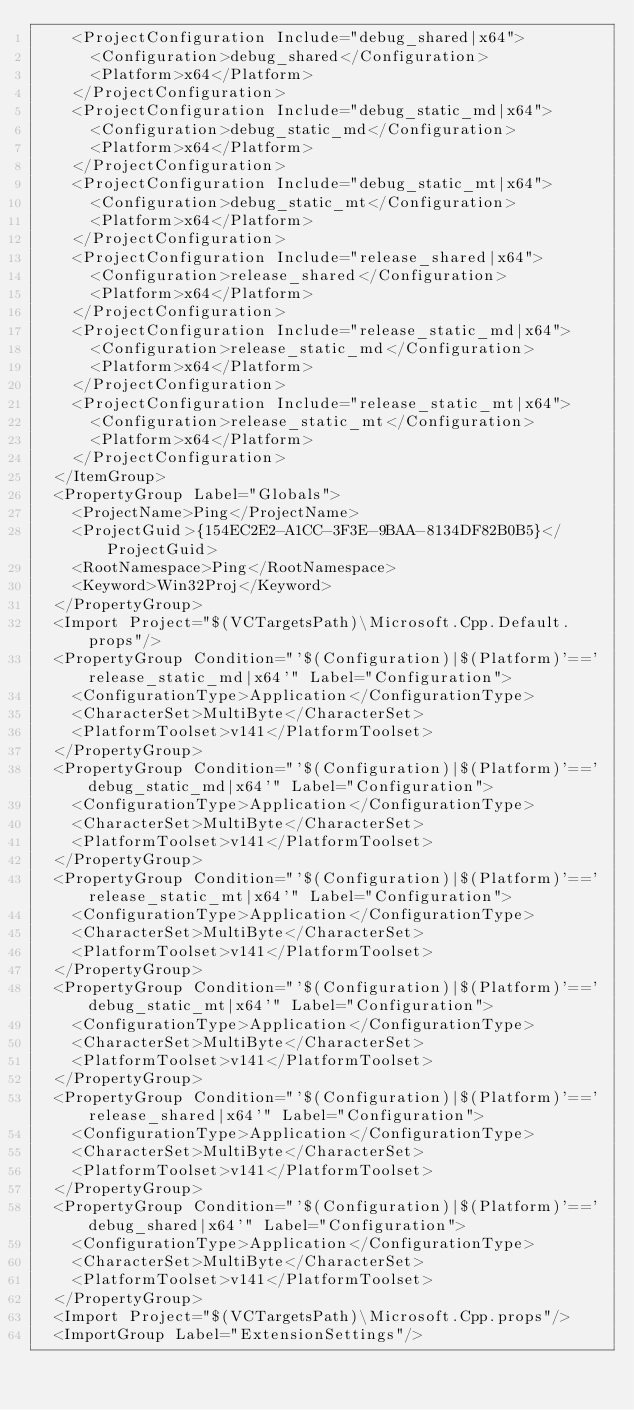<code> <loc_0><loc_0><loc_500><loc_500><_XML_>    <ProjectConfiguration Include="debug_shared|x64">
      <Configuration>debug_shared</Configuration>
      <Platform>x64</Platform>
    </ProjectConfiguration>
    <ProjectConfiguration Include="debug_static_md|x64">
      <Configuration>debug_static_md</Configuration>
      <Platform>x64</Platform>
    </ProjectConfiguration>
    <ProjectConfiguration Include="debug_static_mt|x64">
      <Configuration>debug_static_mt</Configuration>
      <Platform>x64</Platform>
    </ProjectConfiguration>
    <ProjectConfiguration Include="release_shared|x64">
      <Configuration>release_shared</Configuration>
      <Platform>x64</Platform>
    </ProjectConfiguration>
    <ProjectConfiguration Include="release_static_md|x64">
      <Configuration>release_static_md</Configuration>
      <Platform>x64</Platform>
    </ProjectConfiguration>
    <ProjectConfiguration Include="release_static_mt|x64">
      <Configuration>release_static_mt</Configuration>
      <Platform>x64</Platform>
    </ProjectConfiguration>
  </ItemGroup>
  <PropertyGroup Label="Globals">
    <ProjectName>Ping</ProjectName>
    <ProjectGuid>{154EC2E2-A1CC-3F3E-9BAA-8134DF82B0B5}</ProjectGuid>
    <RootNamespace>Ping</RootNamespace>
    <Keyword>Win32Proj</Keyword>
  </PropertyGroup>
  <Import Project="$(VCTargetsPath)\Microsoft.Cpp.Default.props"/>
  <PropertyGroup Condition="'$(Configuration)|$(Platform)'=='release_static_md|x64'" Label="Configuration">
    <ConfigurationType>Application</ConfigurationType>
    <CharacterSet>MultiByte</CharacterSet>
    <PlatformToolset>v141</PlatformToolset>
  </PropertyGroup>
  <PropertyGroup Condition="'$(Configuration)|$(Platform)'=='debug_static_md|x64'" Label="Configuration">
    <ConfigurationType>Application</ConfigurationType>
    <CharacterSet>MultiByte</CharacterSet>
    <PlatformToolset>v141</PlatformToolset>
  </PropertyGroup>
  <PropertyGroup Condition="'$(Configuration)|$(Platform)'=='release_static_mt|x64'" Label="Configuration">
    <ConfigurationType>Application</ConfigurationType>
    <CharacterSet>MultiByte</CharacterSet>
    <PlatformToolset>v141</PlatformToolset>
  </PropertyGroup>
  <PropertyGroup Condition="'$(Configuration)|$(Platform)'=='debug_static_mt|x64'" Label="Configuration">
    <ConfigurationType>Application</ConfigurationType>
    <CharacterSet>MultiByte</CharacterSet>
    <PlatformToolset>v141</PlatformToolset>
  </PropertyGroup>
  <PropertyGroup Condition="'$(Configuration)|$(Platform)'=='release_shared|x64'" Label="Configuration">
    <ConfigurationType>Application</ConfigurationType>
    <CharacterSet>MultiByte</CharacterSet>
    <PlatformToolset>v141</PlatformToolset>
  </PropertyGroup>
  <PropertyGroup Condition="'$(Configuration)|$(Platform)'=='debug_shared|x64'" Label="Configuration">
    <ConfigurationType>Application</ConfigurationType>
    <CharacterSet>MultiByte</CharacterSet>
    <PlatformToolset>v141</PlatformToolset>
  </PropertyGroup>
  <Import Project="$(VCTargetsPath)\Microsoft.Cpp.props"/>
  <ImportGroup Label="ExtensionSettings"/></code> 